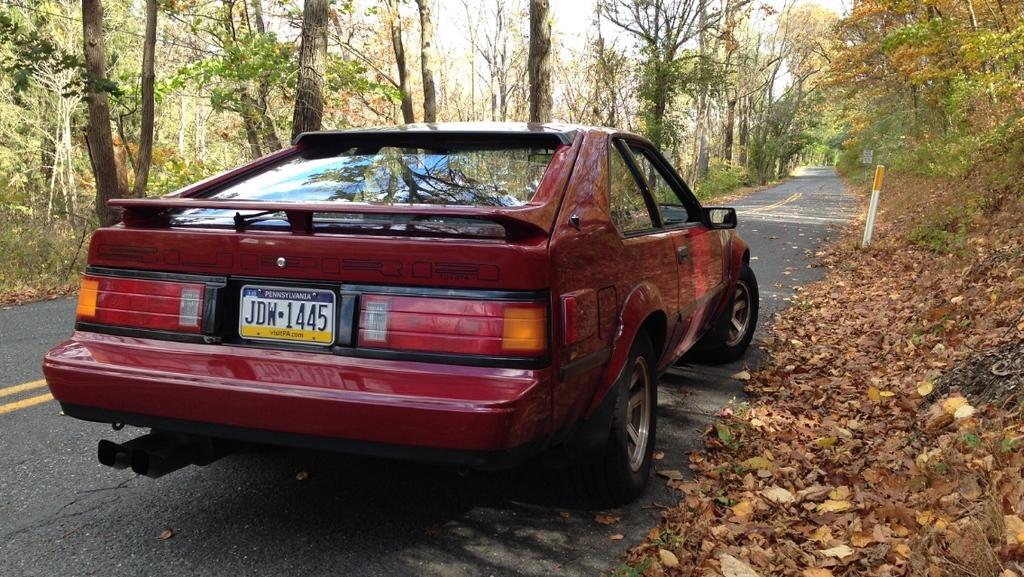In one or two sentences, can you explain what this image depicts? This picture is clicked outside the city. Here, we see a car in red color is moving on the road. On either side of the road, we see trees and in the right bottom of the picture, we see dried leaves and twigs. 